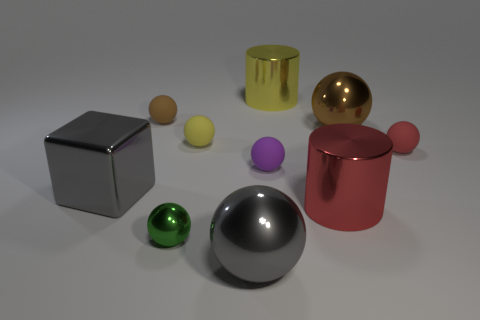Is the color of the big metallic object on the left side of the gray sphere the same as the big metal ball on the left side of the purple rubber ball?
Make the answer very short. Yes. How many things have the same color as the metallic block?
Offer a terse response. 1. Is the number of big red objects behind the large yellow thing less than the number of yellow matte spheres in front of the yellow rubber object?
Provide a succinct answer. No. There is a large brown metallic thing; what number of cylinders are in front of it?
Keep it short and to the point. 1. Is there a small thing that has the same material as the yellow ball?
Make the answer very short. Yes. Is the number of purple spheres right of the block greater than the number of large yellow metallic cylinders that are on the left side of the gray shiny ball?
Offer a very short reply. Yes. The gray cube is what size?
Your answer should be compact. Large. The shiny thing left of the small green object has what shape?
Your response must be concise. Cube. Is the shape of the small brown object the same as the tiny yellow rubber thing?
Your response must be concise. Yes. Is the number of small spheres right of the purple matte sphere the same as the number of large gray shiny spheres?
Your response must be concise. Yes. 